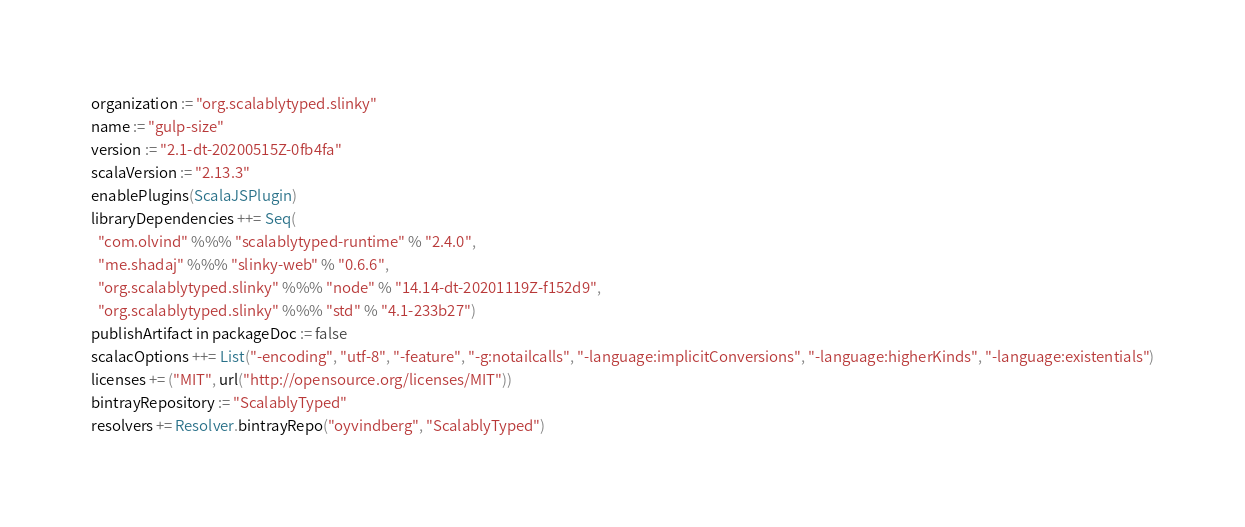<code> <loc_0><loc_0><loc_500><loc_500><_Scala_>organization := "org.scalablytyped.slinky"
name := "gulp-size"
version := "2.1-dt-20200515Z-0fb4fa"
scalaVersion := "2.13.3"
enablePlugins(ScalaJSPlugin)
libraryDependencies ++= Seq(
  "com.olvind" %%% "scalablytyped-runtime" % "2.4.0",
  "me.shadaj" %%% "slinky-web" % "0.6.6",
  "org.scalablytyped.slinky" %%% "node" % "14.14-dt-20201119Z-f152d9",
  "org.scalablytyped.slinky" %%% "std" % "4.1-233b27")
publishArtifact in packageDoc := false
scalacOptions ++= List("-encoding", "utf-8", "-feature", "-g:notailcalls", "-language:implicitConversions", "-language:higherKinds", "-language:existentials")
licenses += ("MIT", url("http://opensource.org/licenses/MIT"))
bintrayRepository := "ScalablyTyped"
resolvers += Resolver.bintrayRepo("oyvindberg", "ScalablyTyped")
</code> 